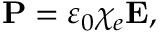Convert formula to latex. <formula><loc_0><loc_0><loc_500><loc_500>P = \varepsilon _ { 0 } \chi _ { e } E ,</formula> 